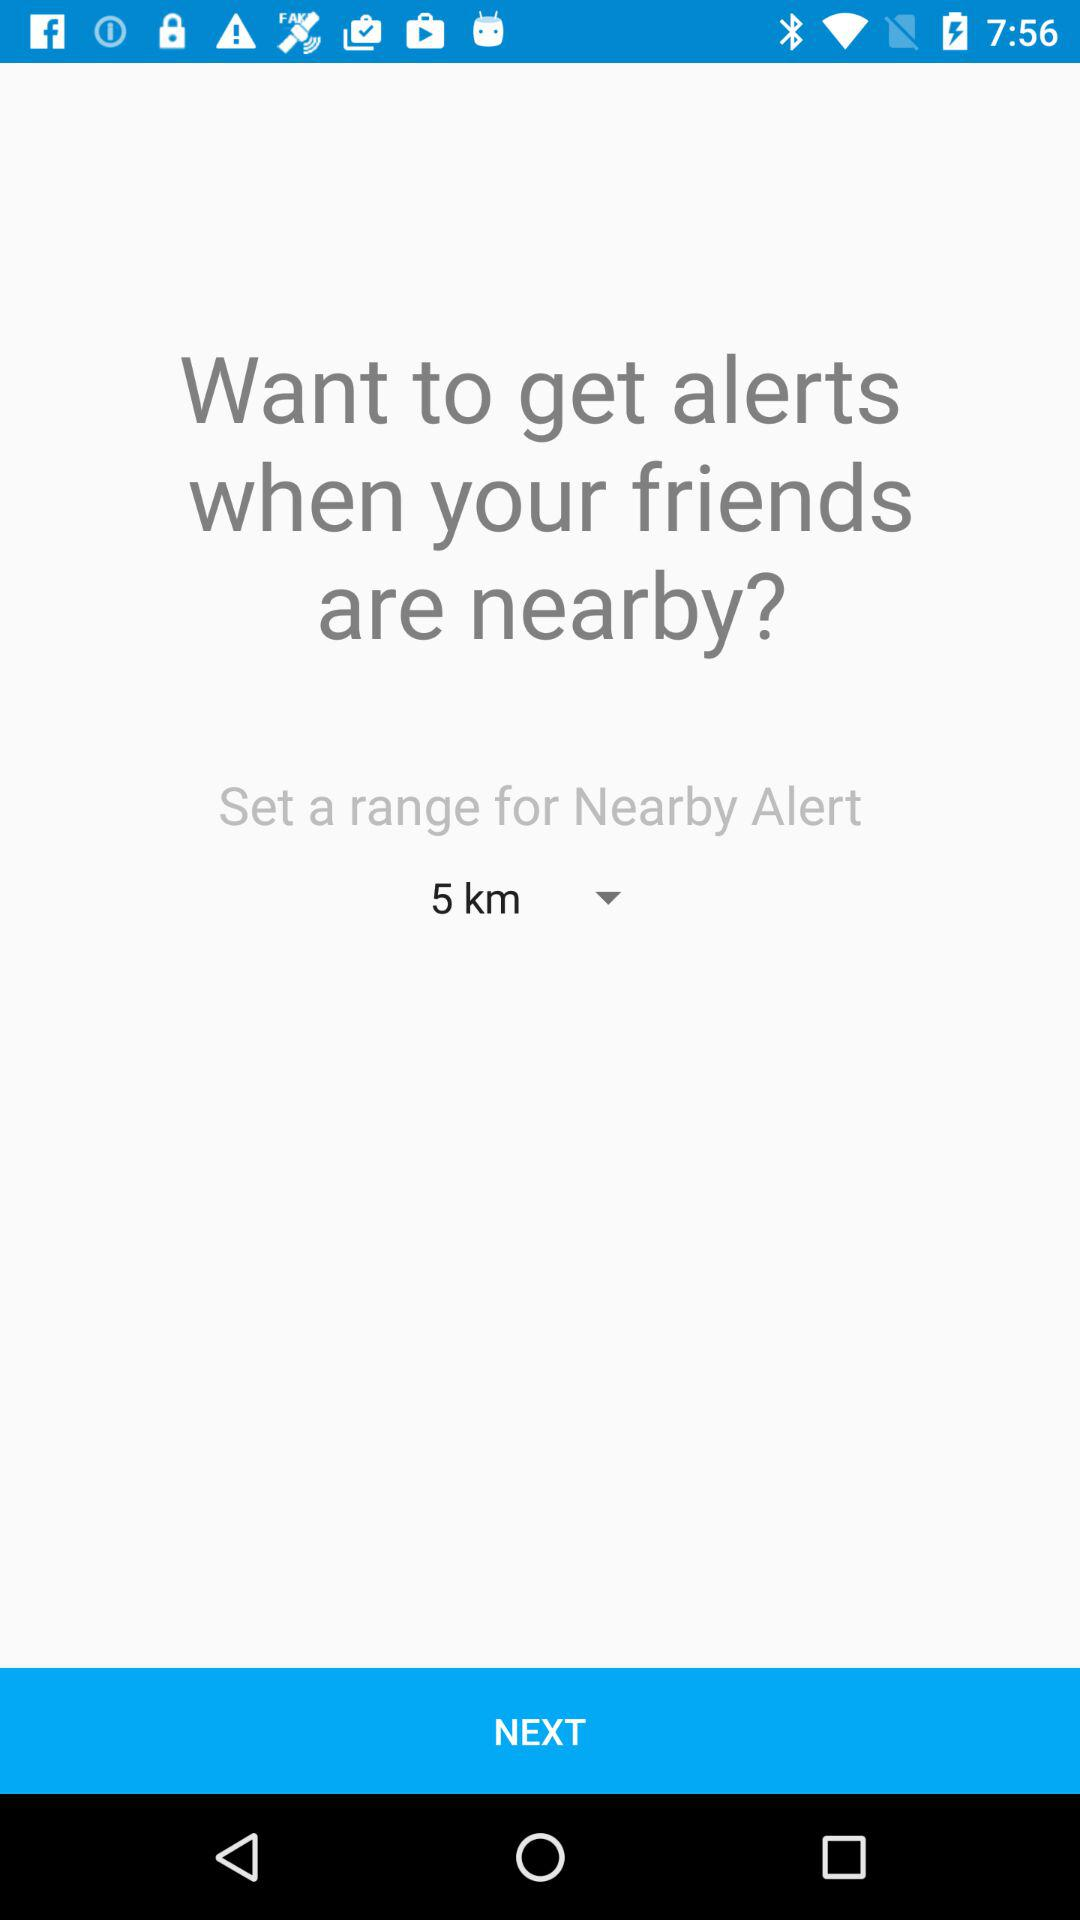What is the range for Nearby Alerts? The range for Nearby Alerts is 5 km. 